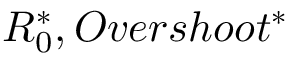Convert formula to latex. <formula><loc_0><loc_0><loc_500><loc_500>R _ { 0 } ^ { * } , O v e r s h o o t ^ { * }</formula> 